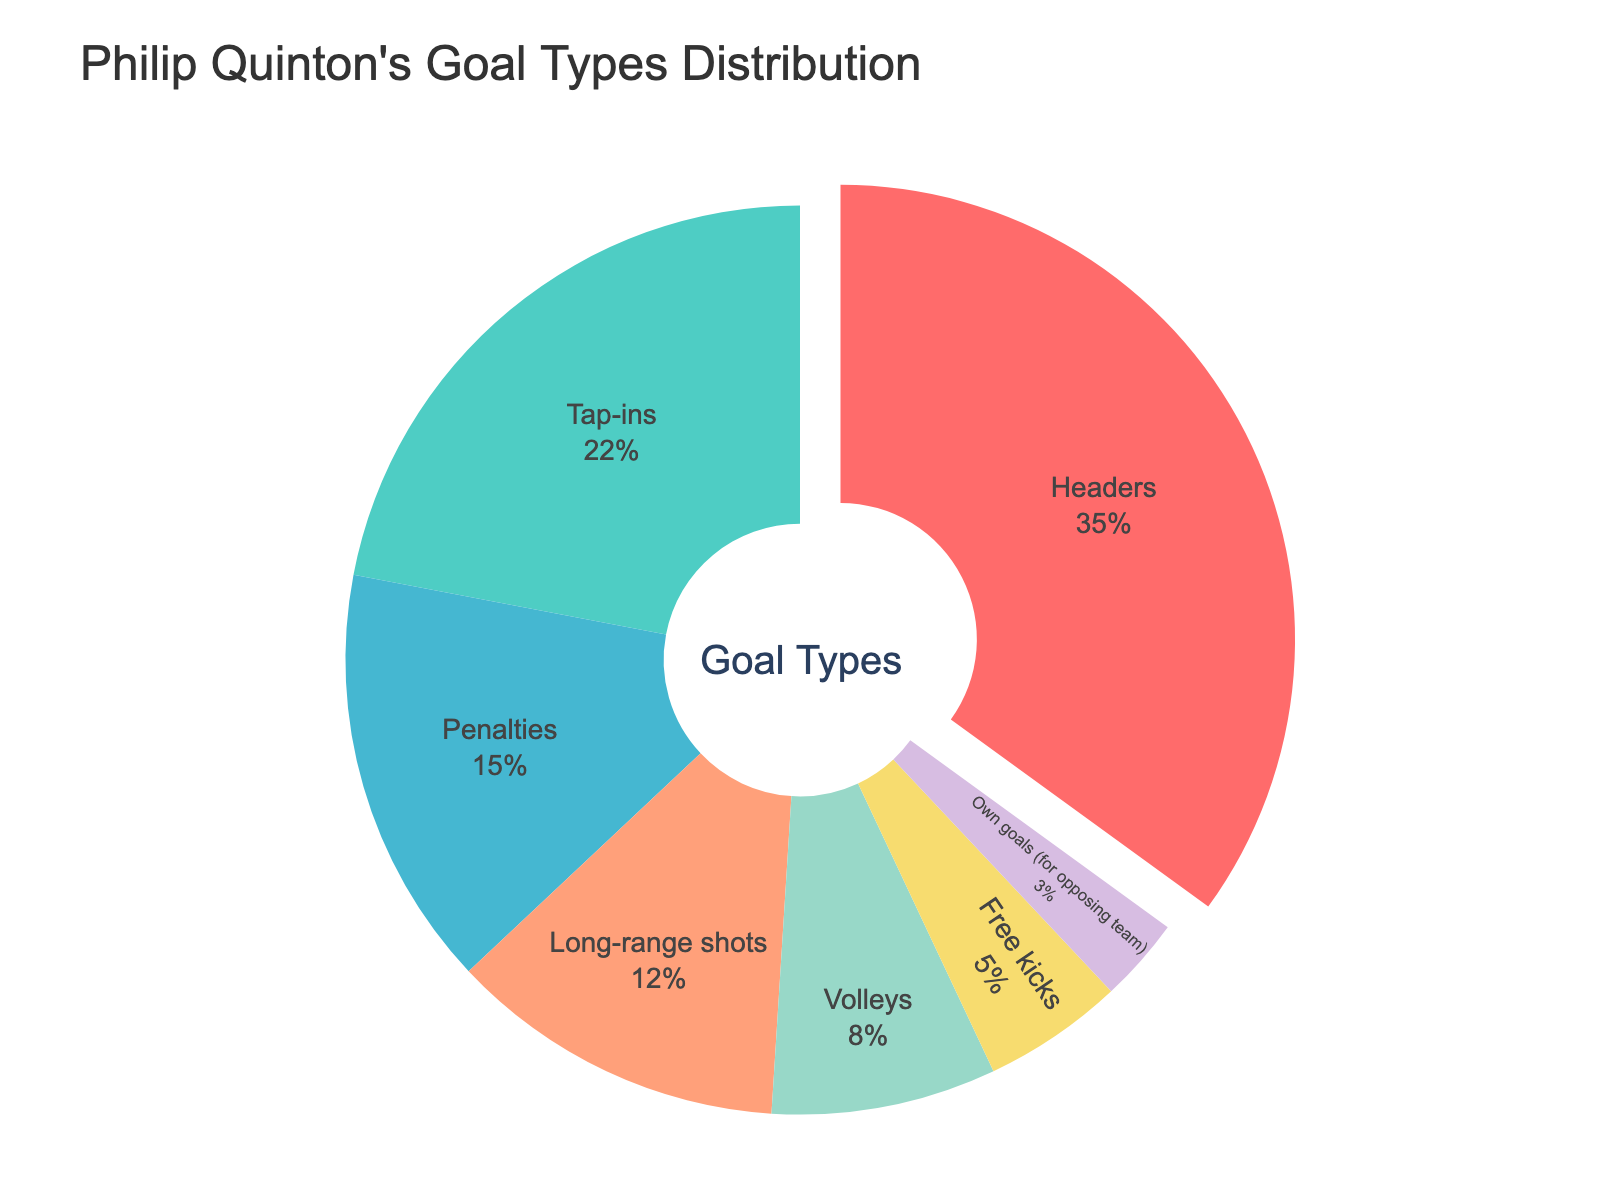Which type of goal does Philip Quinton score the most? The pie chart shows the distribution of different goal types. The segment with the largest portion represents "Headers."
Answer: Headers Does Philip Quinton score more goals through penalties or tap-ins? Compare the size of the segments for penalties and tap-ins. The tap-ins segment is larger.
Answer: Tap-ins What percentage of Phillip Quinton's goals are scored from long-range shots and free kicks combined? Add the percentages of long-range shots (12%) and free kicks (5%), which total (12% + 5%).
Answer: 17% Which goal types account for less than 10% each of Philip Quinton's total goals? Identify the segments with a percentage less than 10%. These are volleys (8%), free kicks (5%), and own goals (3%).
Answer: Volleys, Free kicks, Own goals How much more frequent are headers compared to long-range shots? Determine the difference in percentages between headers (35%) and long-range shots (12%), which is (35% - 12%).
Answer: 23% Are own goals more frequent than free kicks? Compare the percentage for own goals (3%) and free kicks (5%). Free kicks have a higher percentage.
Answer: No What is the average percentage of goals scored from tap-ins, penalties, and volleys? Calculate the average of the percentages for tap-ins (22%), penalties (15%), and volleys (8%). The sum is (22% + 15% + 8% = 45%), and the average is (45% / 3).
Answer: 15% How do headers compare to the combined percentage of penalties and free kicks? Add the percentages for penalties and free kicks (15% + 5%), which results in 20%, and compare it to headers (35%).
Answer: Headers are higher What is the color indicated for the type of goal with the smallest percentage? Identify the segment with the smallest percentage (own goals, 3%) and note its color in the chart, which is purple.
Answer: Purple 